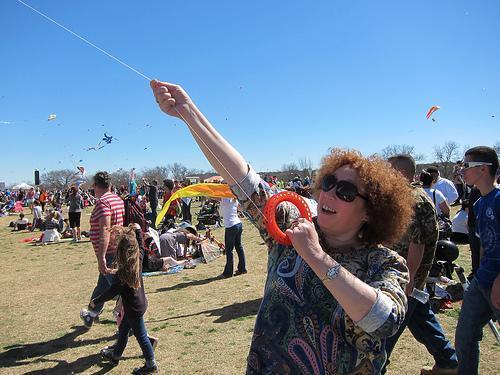How many people are playing football?
Give a very brief answer. 0. 